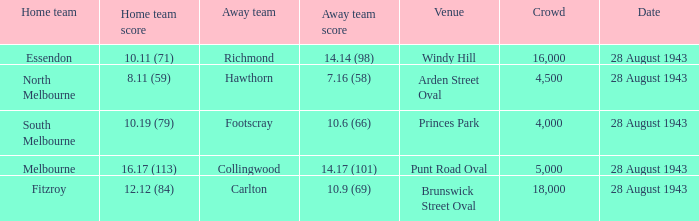What game showed a home team score of 8.11 (59)? 28 August 1943. Could you parse the entire table as a dict? {'header': ['Home team', 'Home team score', 'Away team', 'Away team score', 'Venue', 'Crowd', 'Date'], 'rows': [['Essendon', '10.11 (71)', 'Richmond', '14.14 (98)', 'Windy Hill', '16,000', '28 August 1943'], ['North Melbourne', '8.11 (59)', 'Hawthorn', '7.16 (58)', 'Arden Street Oval', '4,500', '28 August 1943'], ['South Melbourne', '10.19 (79)', 'Footscray', '10.6 (66)', 'Princes Park', '4,000', '28 August 1943'], ['Melbourne', '16.17 (113)', 'Collingwood', '14.17 (101)', 'Punt Road Oval', '5,000', '28 August 1943'], ['Fitzroy', '12.12 (84)', 'Carlton', '10.9 (69)', 'Brunswick Street Oval', '18,000', '28 August 1943']]} 